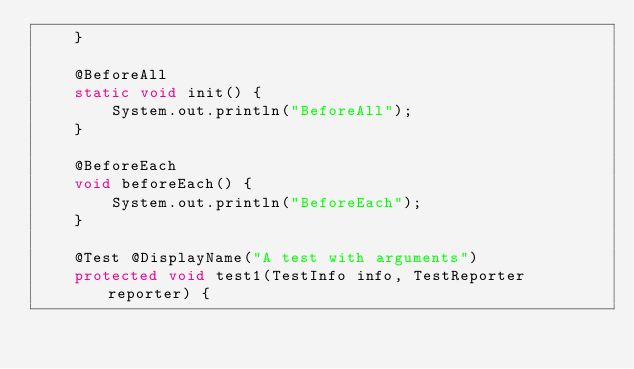Convert code to text. <code><loc_0><loc_0><loc_500><loc_500><_Java_>    }

    @BeforeAll
    static void init() {
        System.out.println("BeforeAll");
    }

    @BeforeEach
    void beforeEach() {
        System.out.println("BeforeEach");
    }

    @Test @DisplayName("A test with arguments")
    protected void test1(TestInfo info, TestReporter reporter) {</code> 